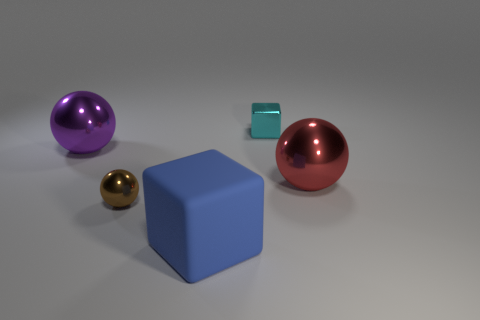How many things are tiny purple cylinders or small shiny blocks?
Offer a very short reply. 1. There is a big thing that is in front of the small shiny thing that is to the left of the cube that is in front of the cyan metallic object; what is its material?
Your response must be concise. Rubber. There is a large thing that is in front of the brown shiny thing; what is it made of?
Offer a very short reply. Rubber. Is there a green sphere that has the same size as the blue matte cube?
Your response must be concise. No. What number of red things are small metallic cubes or large balls?
Provide a short and direct response. 1. How many small metallic blocks have the same color as the rubber object?
Keep it short and to the point. 0. Is the small sphere made of the same material as the tiny cube?
Your answer should be very brief. Yes. What number of objects are right of the sphere left of the small brown thing?
Offer a terse response. 4. Is the cyan thing the same size as the blue matte cube?
Give a very brief answer. No. How many tiny blue cubes are the same material as the tiny brown ball?
Give a very brief answer. 0. 